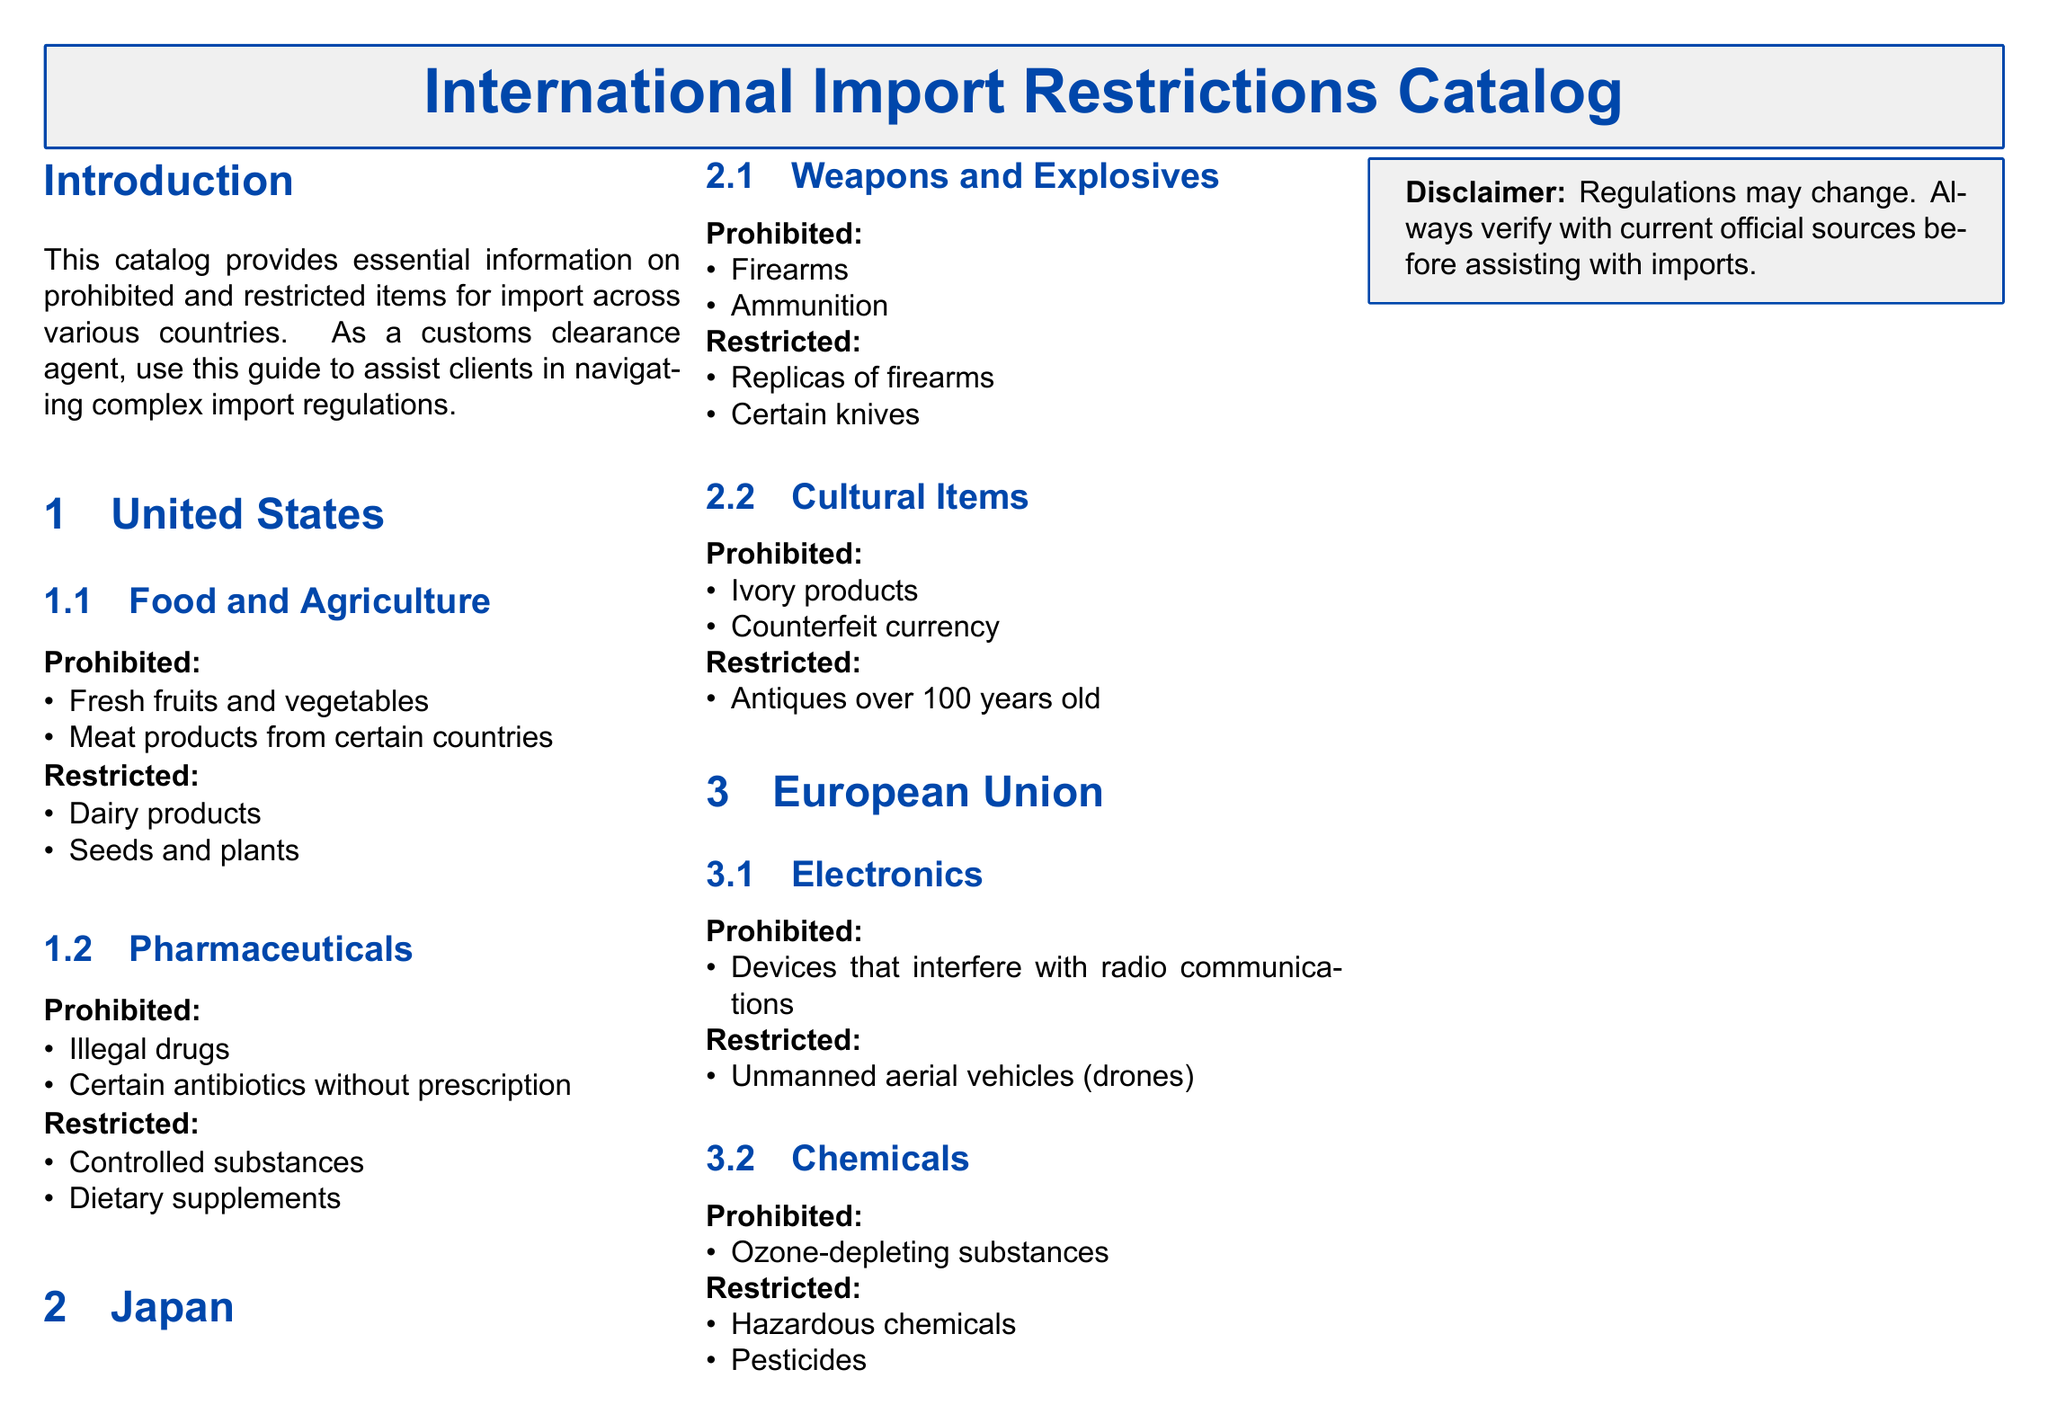what are the prohibited food items in the United States? The document lists prohibited food items under the United States section, which includes fresh fruits and vegetables and meat products from certain countries.
Answer: fresh fruits and vegetables, meat products from certain countries what type of chemicals are prohibited in the European Union? The prohibited chemicals are specifically mentioned in the European Union section, which states ozone-depleting substances.
Answer: Ozone-depleting substances what is an example of a restricted item in Japan? The document lists restricted items in Japan, including replicas of firearms and certain knives.
Answer: replicas of firearms how many categories are listed under the United States section? The United States section contains two main categories: Food and Agriculture, and Pharmaceuticals.
Answer: 2 which item is prohibited under the Cultural Items category in Japan? The document describes the prohibited items in the Cultural Items category in Japan, highlighting ivory products and counterfeit currency.
Answer: ivory products what category does "unmanned aerial vehicles" fall under in the European Union? The document indicates that unmanned aerial vehicles (drones) are listed under the Electronics category as a restricted item.
Answer: Electronics what is the disclaimer in the document regarding regulations? The document provides a disclaimer emphasizing that regulations may change and to verify with current official sources.
Answer: Regulations may change what is the prohibited pharmaceutical item listed in the United States? Under Pharmaceuticals in the United States section, the document identifies illegal drugs and certain antibiotics without prescription as prohibited items.
Answer: illegal drugs, certain antibiotics without prescription 